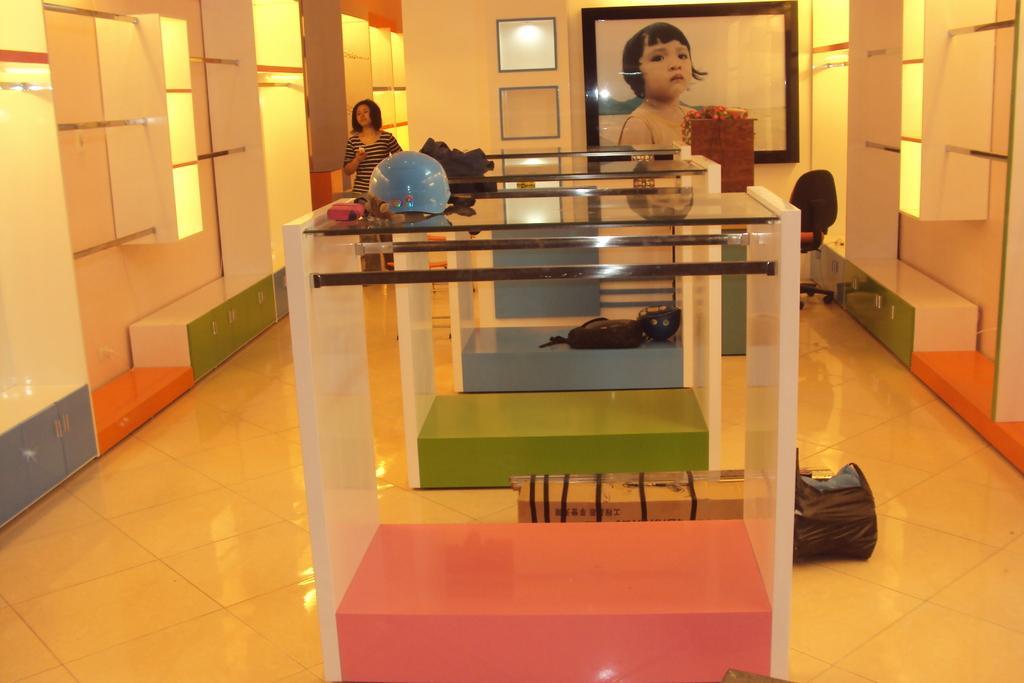How would you summarize this image in a sentence or two? This image is clicked in a room. There are frames on the backside. There is a woman standing on the left side. There is a bag in the right side. There are shelves in the right and left side. 